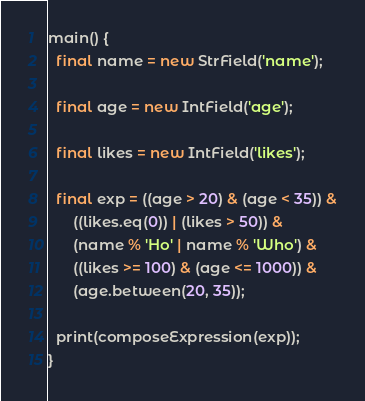Convert code to text. <code><loc_0><loc_0><loc_500><loc_500><_Dart_>main() {
  final name = new StrField('name');

  final age = new IntField('age');

  final likes = new IntField('likes');

  final exp = ((age > 20) & (age < 35)) &
      ((likes.eq(0)) | (likes > 50)) &
      (name % 'Ho' | name % 'Who') &
      ((likes >= 100) & (age <= 1000)) &
      (age.between(20, 35));

  print(composeExpression(exp));
}
</code> 